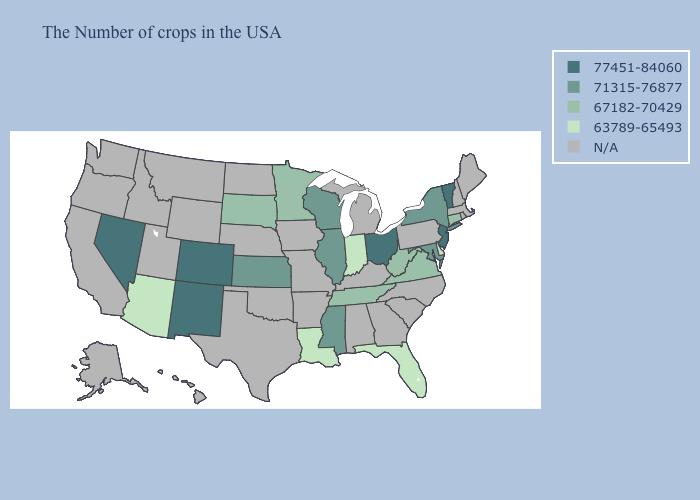Name the states that have a value in the range 71315-76877?
Keep it brief. New York, Maryland, Wisconsin, Illinois, Mississippi, Kansas. Among the states that border Connecticut , which have the highest value?
Write a very short answer. New York. Name the states that have a value in the range 77451-84060?
Write a very short answer. Vermont, New Jersey, Ohio, Colorado, New Mexico, Nevada. What is the highest value in the USA?
Quick response, please. 77451-84060. Does the map have missing data?
Be succinct. Yes. Does Wisconsin have the highest value in the USA?
Be succinct. No. Name the states that have a value in the range 77451-84060?
Answer briefly. Vermont, New Jersey, Ohio, Colorado, New Mexico, Nevada. Does the map have missing data?
Write a very short answer. Yes. Name the states that have a value in the range N/A?
Be succinct. Maine, Massachusetts, Rhode Island, New Hampshire, Pennsylvania, North Carolina, South Carolina, Georgia, Michigan, Kentucky, Alabama, Missouri, Arkansas, Iowa, Nebraska, Oklahoma, Texas, North Dakota, Wyoming, Utah, Montana, Idaho, California, Washington, Oregon, Alaska, Hawaii. Is the legend a continuous bar?
Keep it brief. No. Which states hav the highest value in the MidWest?
Write a very short answer. Ohio. Name the states that have a value in the range 63789-65493?
Keep it brief. Delaware, Florida, Indiana, Louisiana, Arizona. Does the first symbol in the legend represent the smallest category?
Give a very brief answer. No. What is the lowest value in the West?
Quick response, please. 63789-65493. 